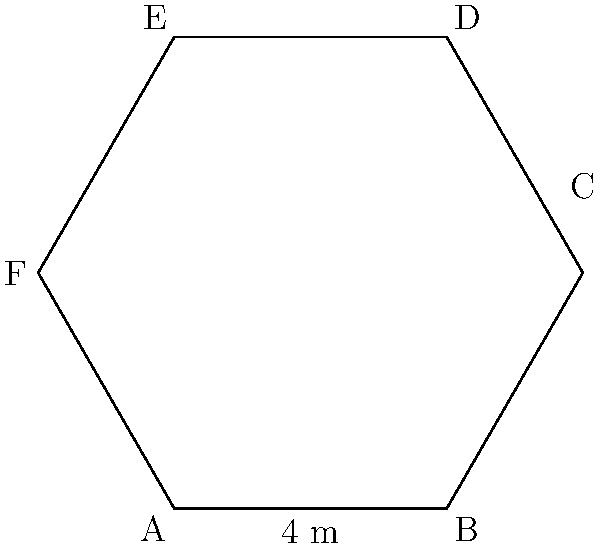A cannabis grow room is designed in the shape of a regular hexagon. If one side of the hexagon measures 4 meters, what is the total perimeter of the grow room? To calculate the perimeter of a regular hexagon, we need to follow these steps:

1. Recognize that a regular hexagon has 6 equal sides.
2. We are given that one side measures 4 meters.
3. To find the perimeter, we multiply the length of one side by the number of sides:

   $$\text{Perimeter} = 6 \times \text{side length}$$
   $$\text{Perimeter} = 6 \times 4 \text{ meters}$$
   $$\text{Perimeter} = 24 \text{ meters}$$

Therefore, the total perimeter of the hexagonal cannabis grow room is 24 meters.
Answer: 24 meters 